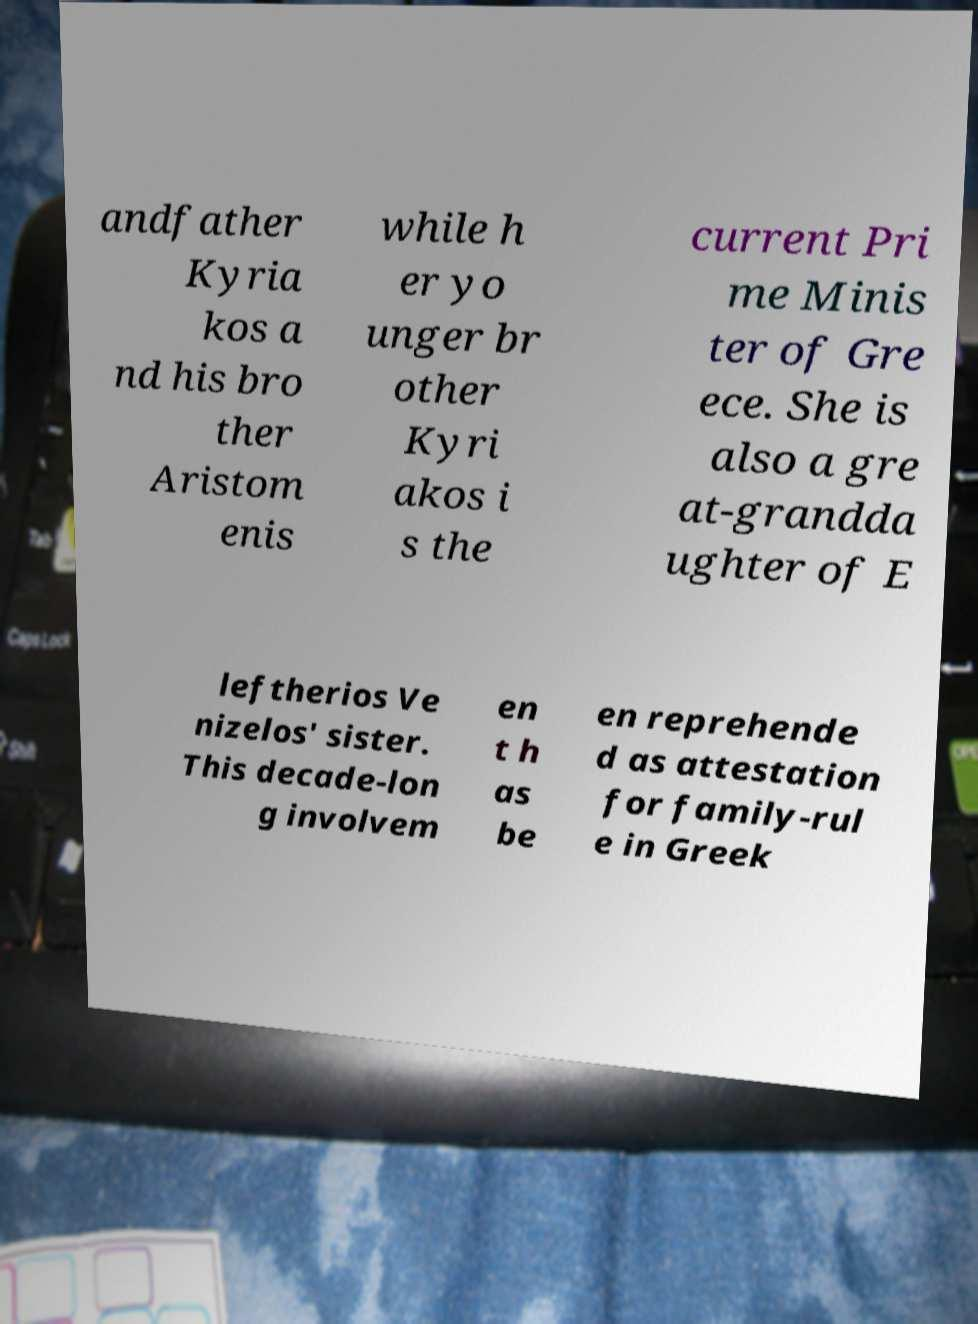Could you extract and type out the text from this image? andfather Kyria kos a nd his bro ther Aristom enis while h er yo unger br other Kyri akos i s the current Pri me Minis ter of Gre ece. She is also a gre at-grandda ughter of E leftherios Ve nizelos' sister. This decade-lon g involvem en t h as be en reprehende d as attestation for family-rul e in Greek 